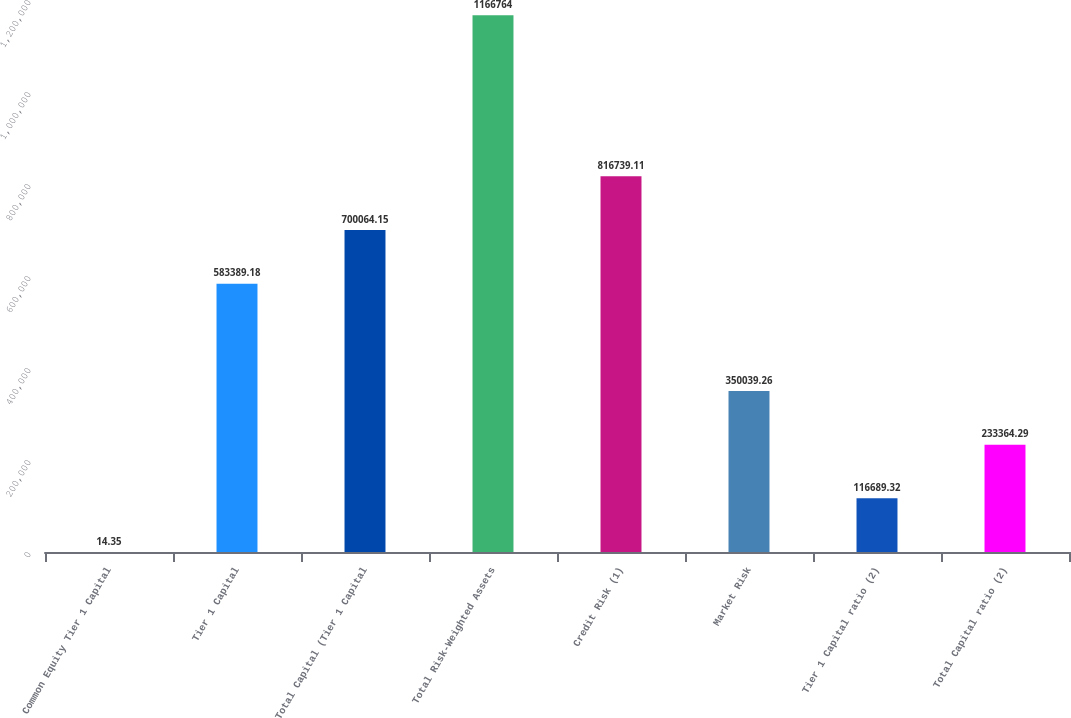Convert chart to OTSL. <chart><loc_0><loc_0><loc_500><loc_500><bar_chart><fcel>Common Equity Tier 1 Capital<fcel>Tier 1 Capital<fcel>Total Capital (Tier 1 Capital<fcel>Total Risk-Weighted Assets<fcel>Credit Risk (1)<fcel>Market Risk<fcel>Tier 1 Capital ratio (2)<fcel>Total Capital ratio (2)<nl><fcel>14.35<fcel>583389<fcel>700064<fcel>1.16676e+06<fcel>816739<fcel>350039<fcel>116689<fcel>233364<nl></chart> 